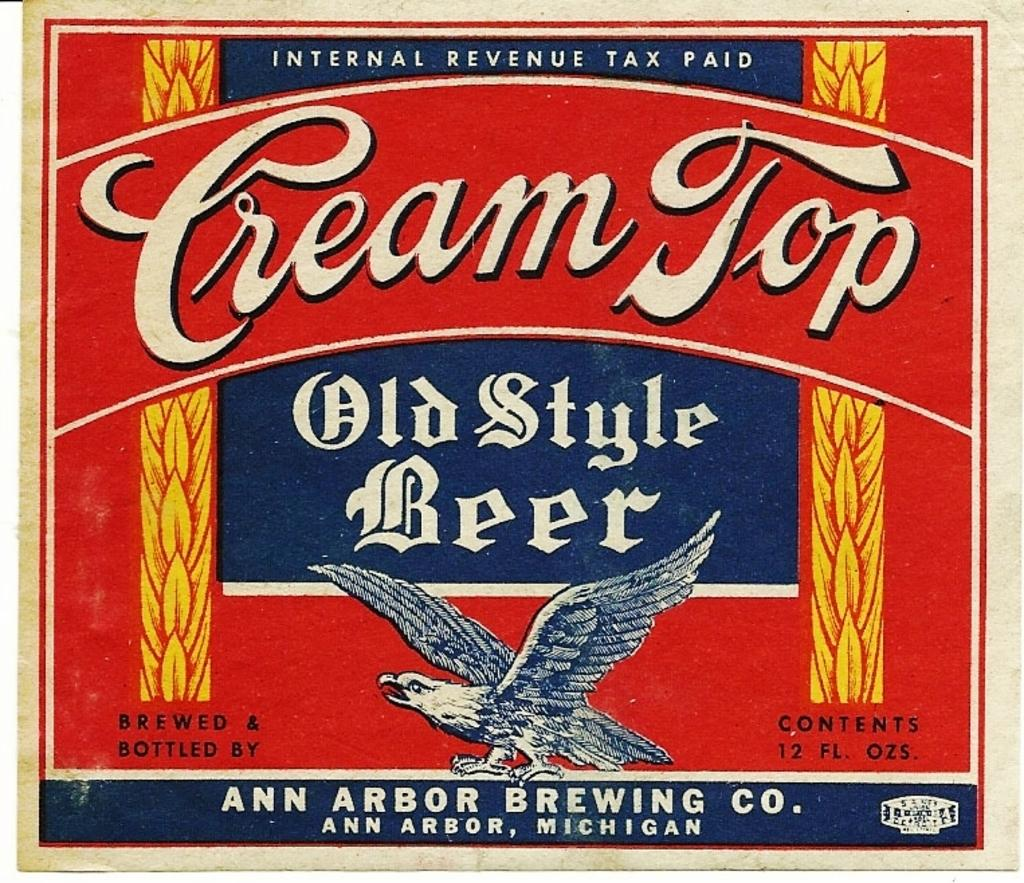What is the main image on the poster in the image? The poster has an animated image of a bird. What color are the texts on the poster? There are white color texts on the poster. What other colors are used for the designs on the poster? There are yellow color designs on the poster. Are there any other colors used for the texts on the poster? Yes, there are texts in other colors on the poster. What is the color of the background on the poster? The background of the poster is red in color. How many geese are present in the image? There are no geese present in the image; it features an animated bird. What are the girls doing in the image? There are no girls present in the image; it is a poster with an animated bird and text. 